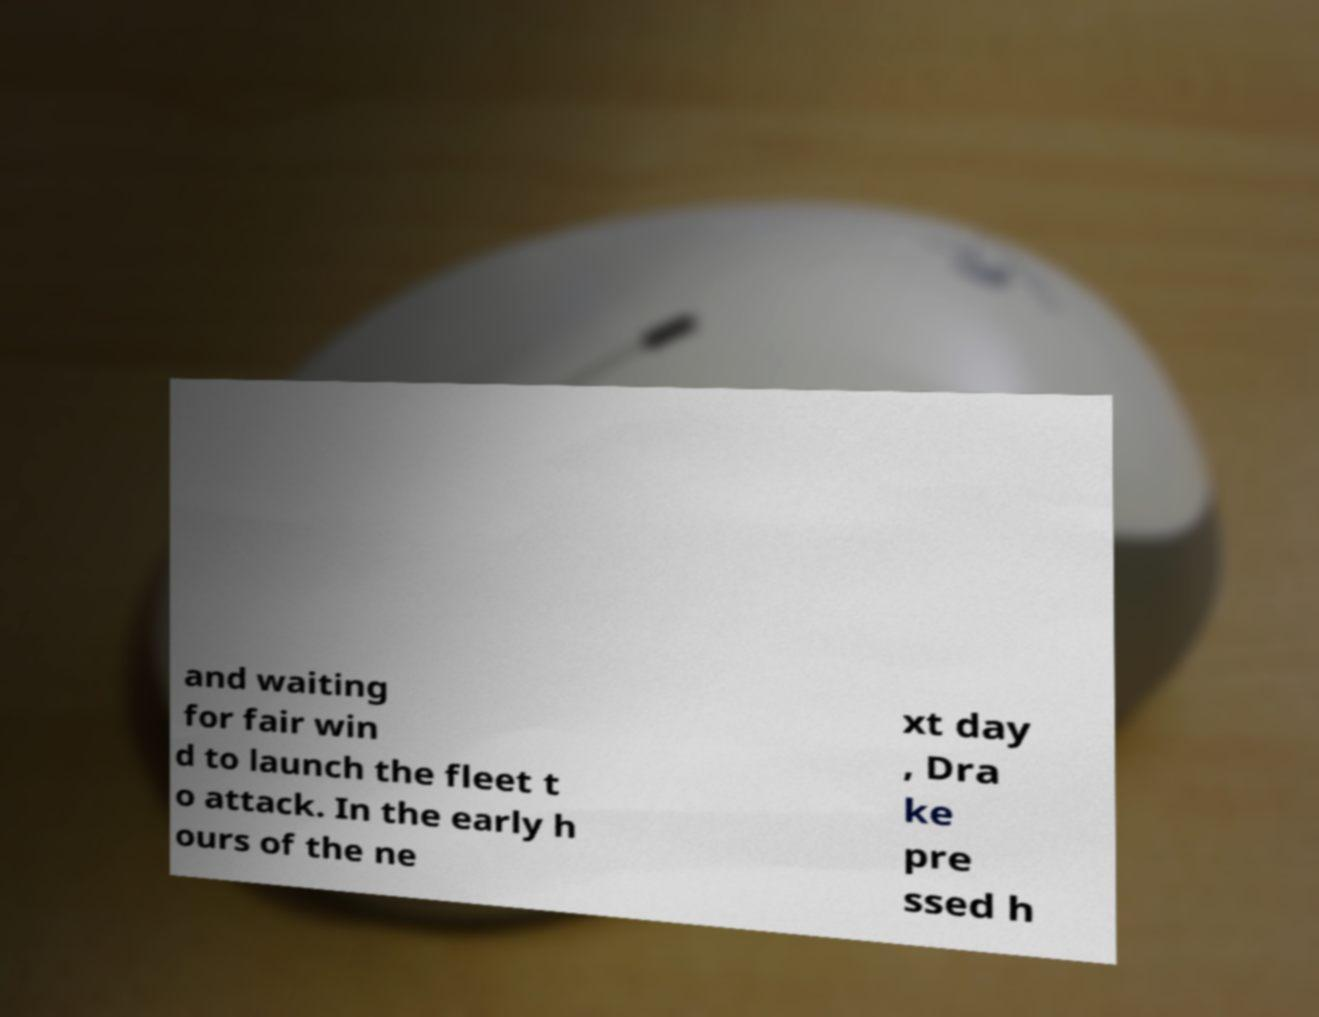Can you accurately transcribe the text from the provided image for me? and waiting for fair win d to launch the fleet t o attack. In the early h ours of the ne xt day , Dra ke pre ssed h 